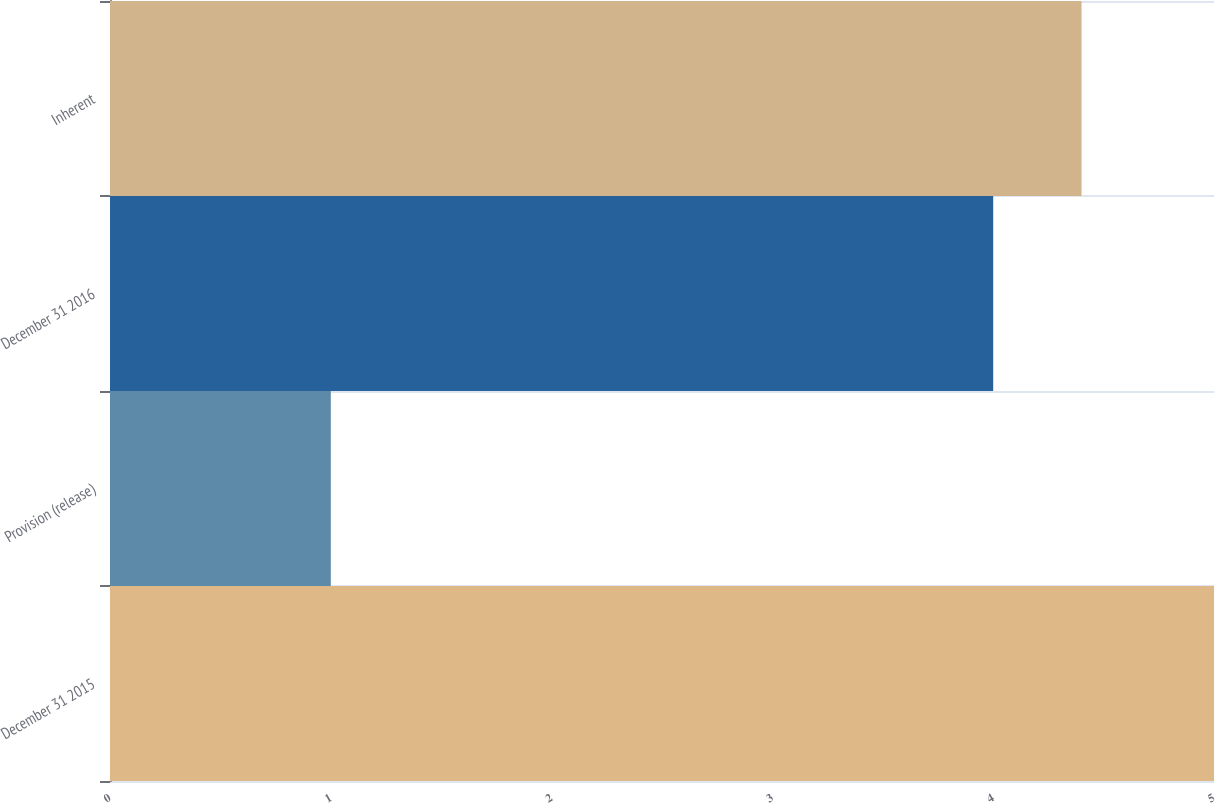Convert chart to OTSL. <chart><loc_0><loc_0><loc_500><loc_500><bar_chart><fcel>December 31 2015<fcel>Provision (release)<fcel>December 31 2016<fcel>Inherent<nl><fcel>5<fcel>1<fcel>4<fcel>4.4<nl></chart> 